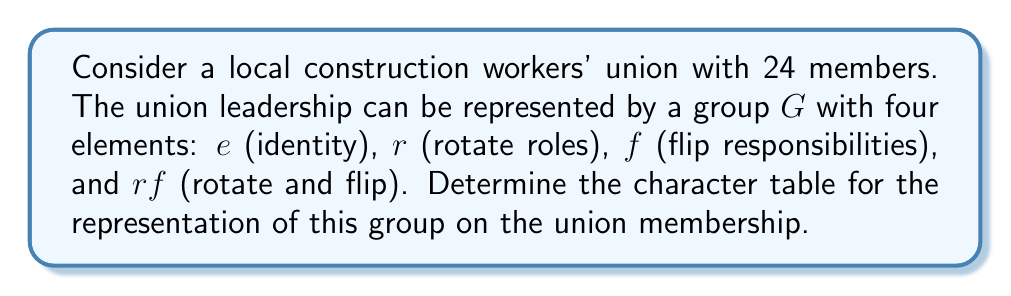Help me with this question. Let's approach this step-by-step:

1) First, we need to understand the group structure. This group $G$ is isomorphic to the Klein four-group $V_4$.

2) The group has four conjugacy classes, each containing one element: $\{e\}$, $\{r\}$, $\{f\}$, and $\{rf\}$.

3) Since there are four conjugacy classes, there will be four irreducible representations.

4) The character table will be a 4x4 matrix.

5) The first row of the character table always corresponds to the trivial representation, where all elements map to 1.

6) The first column always gives the dimension of each representation.

7) For the remaining characters, we can use the orthogonality relations and the fact that the sum of squares of dimensions equals the order of the group.

8) Let's call our representations $\chi_1$ (trivial), $\chi_2$, $\chi_3$, and $\chi_4$. We know $\chi_1 = (1,1,1,1)$.

9) Due to the structure of $V_4$, all representations are 1-dimensional. So our character table will look like:

   $$
   \begin{array}{c|cccc}
     & e & r & f & rf \\
   \hline
   \chi_1 & 1 & 1 & 1 & 1 \\
   \chi_2 & 1 & 1 & -1 & -1 \\
   \chi_3 & 1 & -1 & 1 & -1 \\
   \chi_4 & 1 & -1 & -1 & 1
   \end{array}
   $$

10) This satisfies orthogonality and the sum of squares of dimensions (1^2 + 1^2 + 1^2 + 1^2 = 4).

11) In terms of the union, $\chi_2$ could represent whether a member's role changes under rotation, $\chi_3$ under flipping, and $\chi_4$ under both.
Answer: $$
\begin{array}{c|cccc}
  & e & r & f & rf \\
\hline
\chi_1 & 1 & 1 & 1 & 1 \\
\chi_2 & 1 & 1 & -1 & -1 \\
\chi_3 & 1 & -1 & 1 & -1 \\
\chi_4 & 1 & -1 & -1 & 1
\end{array}
$$ 